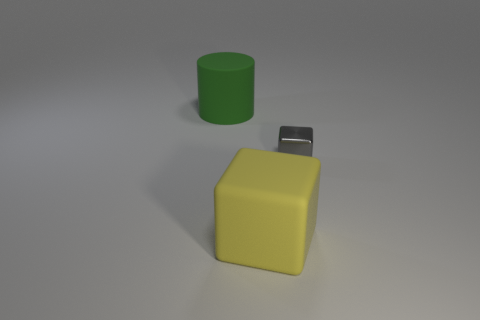Add 2 green cylinders. How many objects exist? 5 Subtract 1 cylinders. How many cylinders are left? 0 Subtract all gray cubes. How many cubes are left? 1 Subtract all blocks. How many objects are left? 1 Subtract 0 yellow balls. How many objects are left? 3 Subtract all yellow cylinders. Subtract all red balls. How many cylinders are left? 1 Subtract all blue spheres. How many gray cubes are left? 1 Subtract all small gray blocks. Subtract all green matte objects. How many objects are left? 1 Add 3 large yellow rubber things. How many large yellow rubber things are left? 4 Add 1 small red rubber objects. How many small red rubber objects exist? 1 